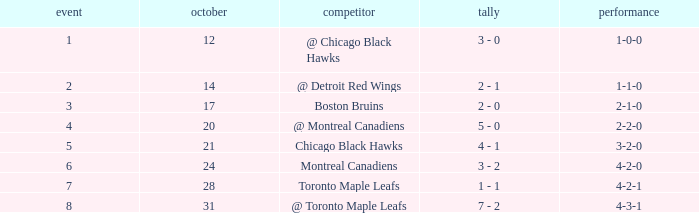What was the score of the game after game 6 on October 28? 1 - 1. 